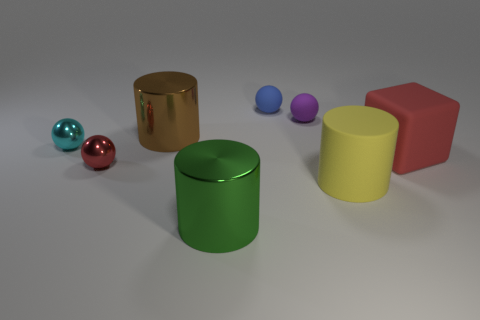Is the material of the tiny cyan ball the same as the red block?
Offer a terse response. No. How many things are big metallic things that are in front of the big yellow object or things that are behind the green metal object?
Your answer should be compact. 8. Are there any brown cubes of the same size as the cyan shiny object?
Give a very brief answer. No. What color is the other large rubber thing that is the same shape as the green thing?
Keep it short and to the point. Yellow. Are there any rubber blocks behind the big shiny cylinder behind the cyan ball?
Offer a terse response. No. Is the shape of the red object that is to the right of the blue rubber ball the same as  the tiny purple thing?
Provide a succinct answer. No. The tiny purple object has what shape?
Offer a terse response. Sphere. What number of other small things have the same material as the green object?
Make the answer very short. 2. There is a matte cylinder; is its color the same as the metal cylinder that is in front of the large yellow thing?
Your response must be concise. No. What number of shiny things are there?
Give a very brief answer. 4. 